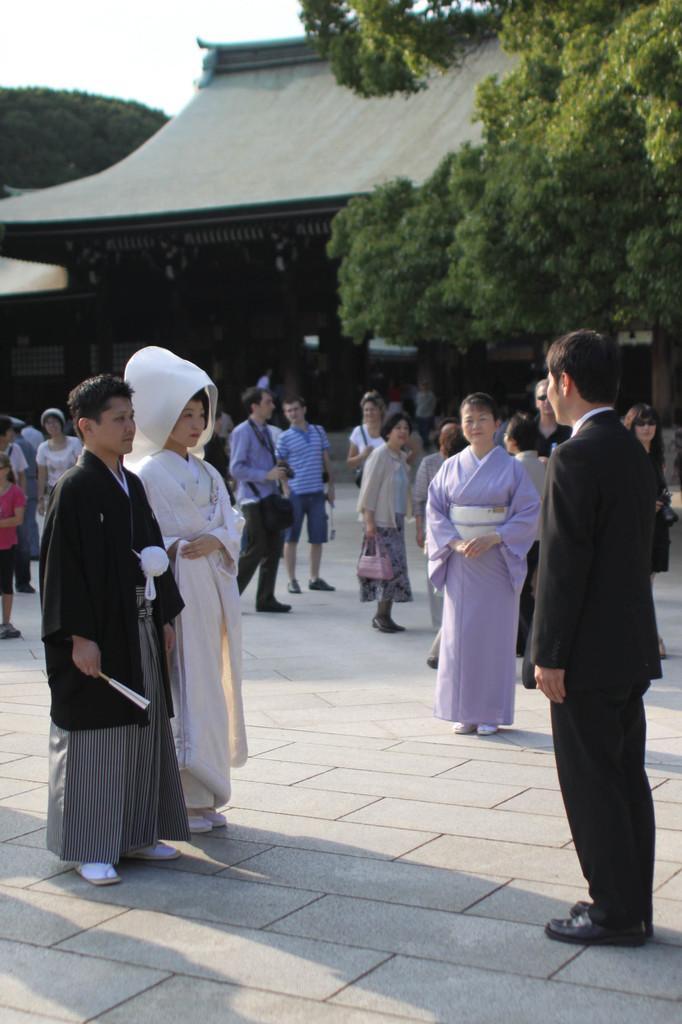How would you summarize this image in a sentence or two? This picture is clicked outside. In the foreground we can see the group of people standing on the ground. In the background there is a sky, house and trees. 